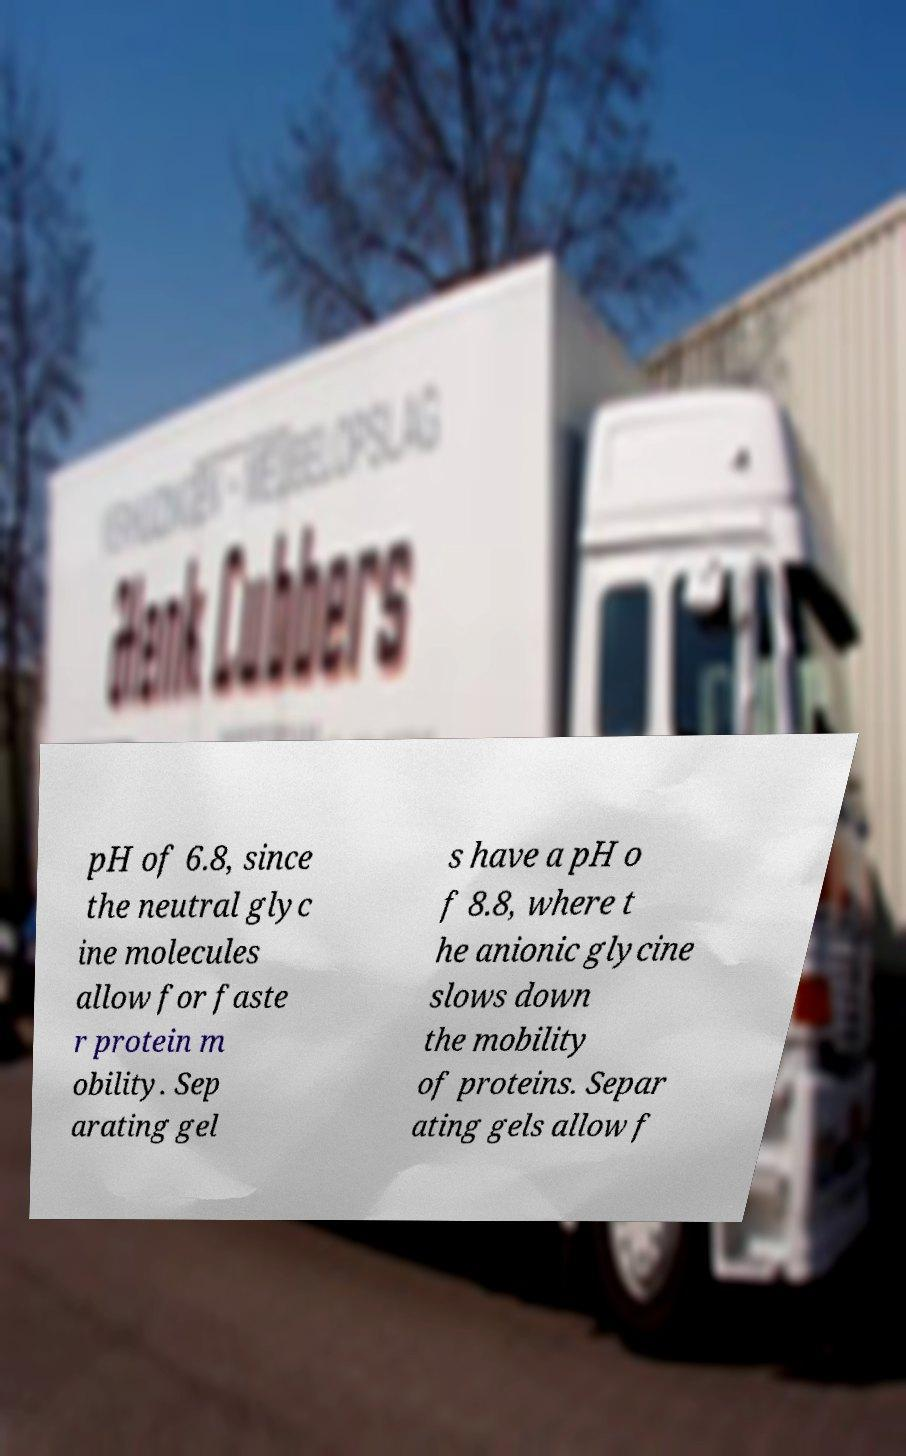Please read and relay the text visible in this image. What does it say? pH of 6.8, since the neutral glyc ine molecules allow for faste r protein m obility. Sep arating gel s have a pH o f 8.8, where t he anionic glycine slows down the mobility of proteins. Separ ating gels allow f 